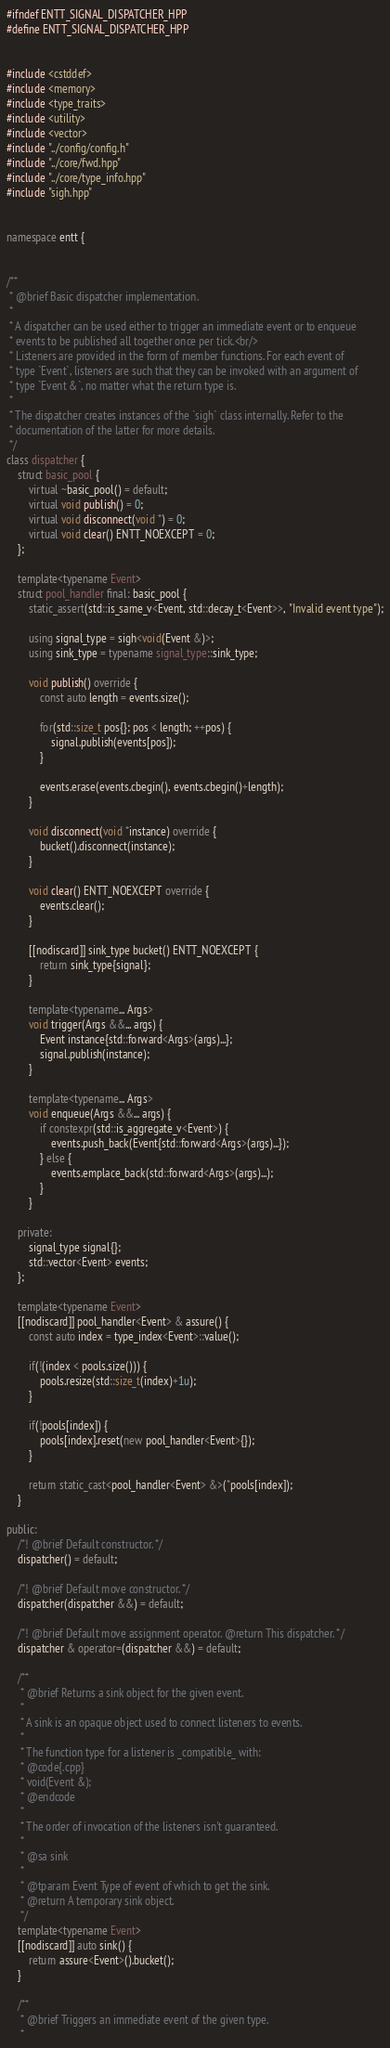Convert code to text. <code><loc_0><loc_0><loc_500><loc_500><_C++_>#ifndef ENTT_SIGNAL_DISPATCHER_HPP
#define ENTT_SIGNAL_DISPATCHER_HPP


#include <cstddef>
#include <memory>
#include <type_traits>
#include <utility>
#include <vector>
#include "../config/config.h"
#include "../core/fwd.hpp"
#include "../core/type_info.hpp"
#include "sigh.hpp"


namespace entt {


/**
 * @brief Basic dispatcher implementation.
 *
 * A dispatcher can be used either to trigger an immediate event or to enqueue
 * events to be published all together once per tick.<br/>
 * Listeners are provided in the form of member functions. For each event of
 * type `Event`, listeners are such that they can be invoked with an argument of
 * type `Event &`, no matter what the return type is.
 *
 * The dispatcher creates instances of the `sigh` class internally. Refer to the
 * documentation of the latter for more details.
 */
class dispatcher {
    struct basic_pool {
        virtual ~basic_pool() = default;
        virtual void publish() = 0;
        virtual void disconnect(void *) = 0;
        virtual void clear() ENTT_NOEXCEPT = 0;
    };

    template<typename Event>
    struct pool_handler final: basic_pool {
        static_assert(std::is_same_v<Event, std::decay_t<Event>>, "Invalid event type");

        using signal_type = sigh<void(Event &)>;
        using sink_type = typename signal_type::sink_type;

        void publish() override {
            const auto length = events.size();

            for(std::size_t pos{}; pos < length; ++pos) {
                signal.publish(events[pos]);
            }

            events.erase(events.cbegin(), events.cbegin()+length);
        }

        void disconnect(void *instance) override {
            bucket().disconnect(instance);
        }

        void clear() ENTT_NOEXCEPT override {
            events.clear();
        }

        [[nodiscard]] sink_type bucket() ENTT_NOEXCEPT {
            return sink_type{signal};
        }

        template<typename... Args>
        void trigger(Args &&... args) {
            Event instance{std::forward<Args>(args)...};
            signal.publish(instance);
        }

        template<typename... Args>
        void enqueue(Args &&... args) {
            if constexpr(std::is_aggregate_v<Event>) {
                events.push_back(Event{std::forward<Args>(args)...});
            } else {
                events.emplace_back(std::forward<Args>(args)...);
            }
        }

    private:
        signal_type signal{};
        std::vector<Event> events;
    };

    template<typename Event>
    [[nodiscard]] pool_handler<Event> & assure() {
        const auto index = type_index<Event>::value();

        if(!(index < pools.size())) {
            pools.resize(std::size_t(index)+1u);
        }

        if(!pools[index]) {
            pools[index].reset(new pool_handler<Event>{});
        }

        return static_cast<pool_handler<Event> &>(*pools[index]);
    }

public:
    /*! @brief Default constructor. */
    dispatcher() = default;

    /*! @brief Default move constructor. */
    dispatcher(dispatcher &&) = default;

    /*! @brief Default move assignment operator. @return This dispatcher. */
    dispatcher & operator=(dispatcher &&) = default;

    /**
     * @brief Returns a sink object for the given event.
     *
     * A sink is an opaque object used to connect listeners to events.
     *
     * The function type for a listener is _compatible_ with:
     * @code{.cpp}
     * void(Event &);
     * @endcode
     *
     * The order of invocation of the listeners isn't guaranteed.
     *
     * @sa sink
     *
     * @tparam Event Type of event of which to get the sink.
     * @return A temporary sink object.
     */
    template<typename Event>
    [[nodiscard]] auto sink() {
        return assure<Event>().bucket();
    }

    /**
     * @brief Triggers an immediate event of the given type.
     *</code> 